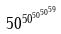<formula> <loc_0><loc_0><loc_500><loc_500>5 0 ^ { 5 0 ^ { 5 0 ^ { 5 0 ^ { 5 9 } } } }</formula> 